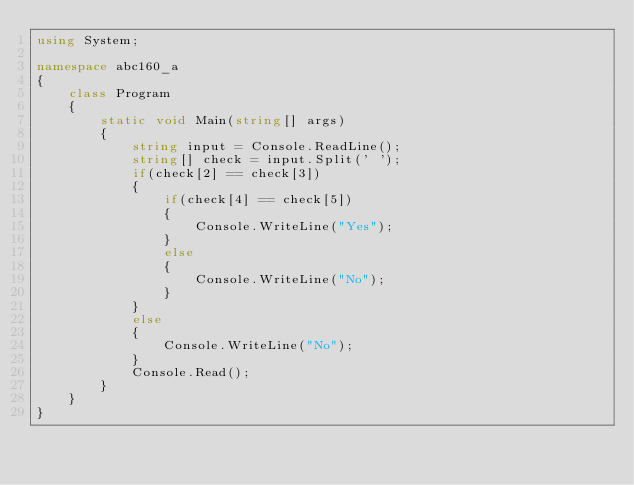<code> <loc_0><loc_0><loc_500><loc_500><_C#_>using System;

namespace abc160_a
{
    class Program
    {
        static void Main(string[] args)
        {
            string input = Console.ReadLine();
            string[] check = input.Split(' ');
            if(check[2] == check[3])
            {
                if(check[4] == check[5])
                {
                    Console.WriteLine("Yes");
                }
                else
                {
                    Console.WriteLine("No");
                }
            }
            else
            {
                Console.WriteLine("No");
            }
            Console.Read();
        }
    }
}</code> 